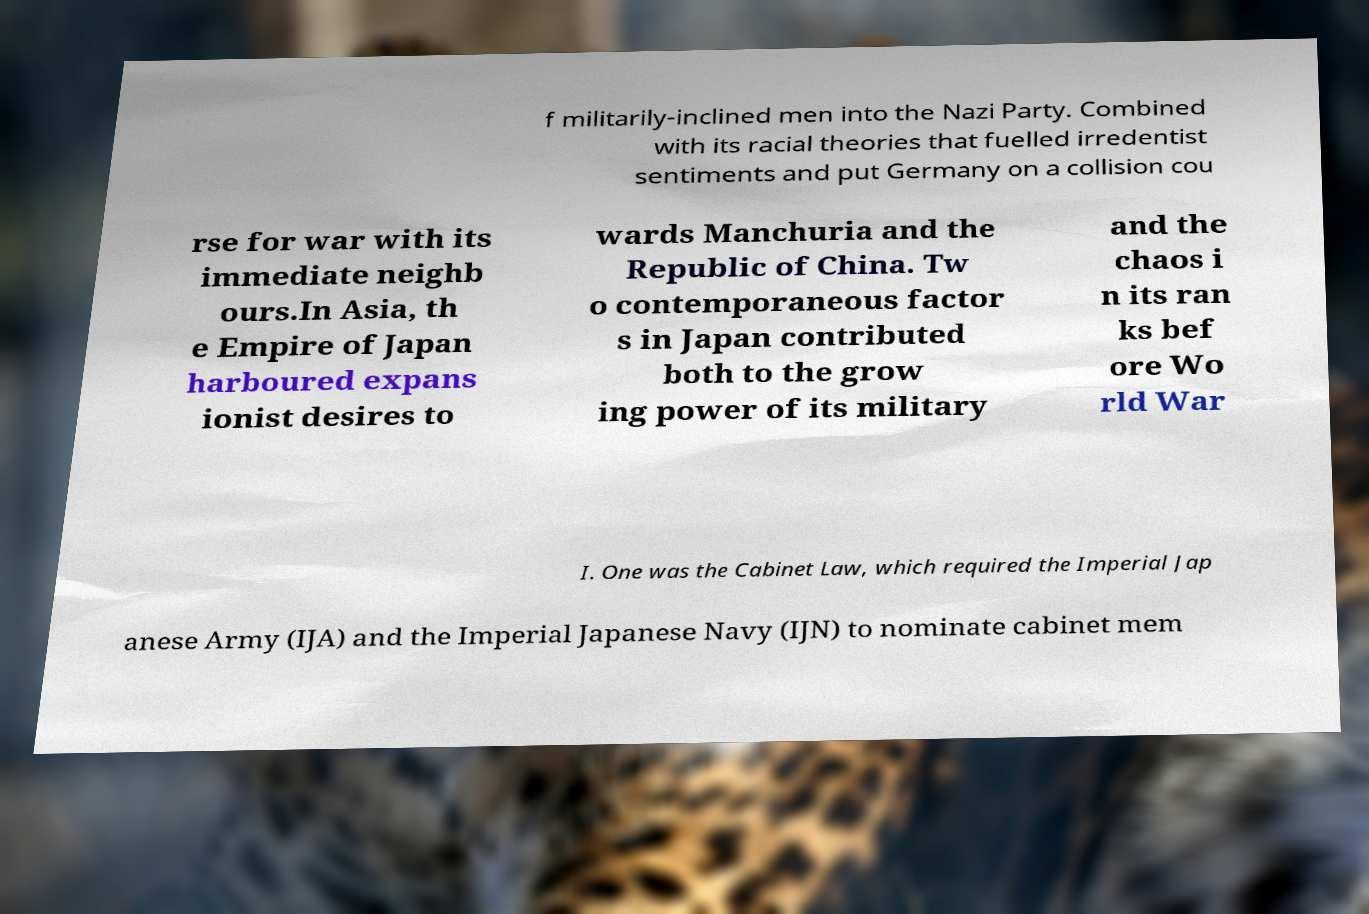I need the written content from this picture converted into text. Can you do that? f militarily-inclined men into the Nazi Party. Combined with its racial theories that fuelled irredentist sentiments and put Germany on a collision cou rse for war with its immediate neighb ours.In Asia, th e Empire of Japan harboured expans ionist desires to wards Manchuria and the Republic of China. Tw o contemporaneous factor s in Japan contributed both to the grow ing power of its military and the chaos i n its ran ks bef ore Wo rld War I. One was the Cabinet Law, which required the Imperial Jap anese Army (IJA) and the Imperial Japanese Navy (IJN) to nominate cabinet mem 